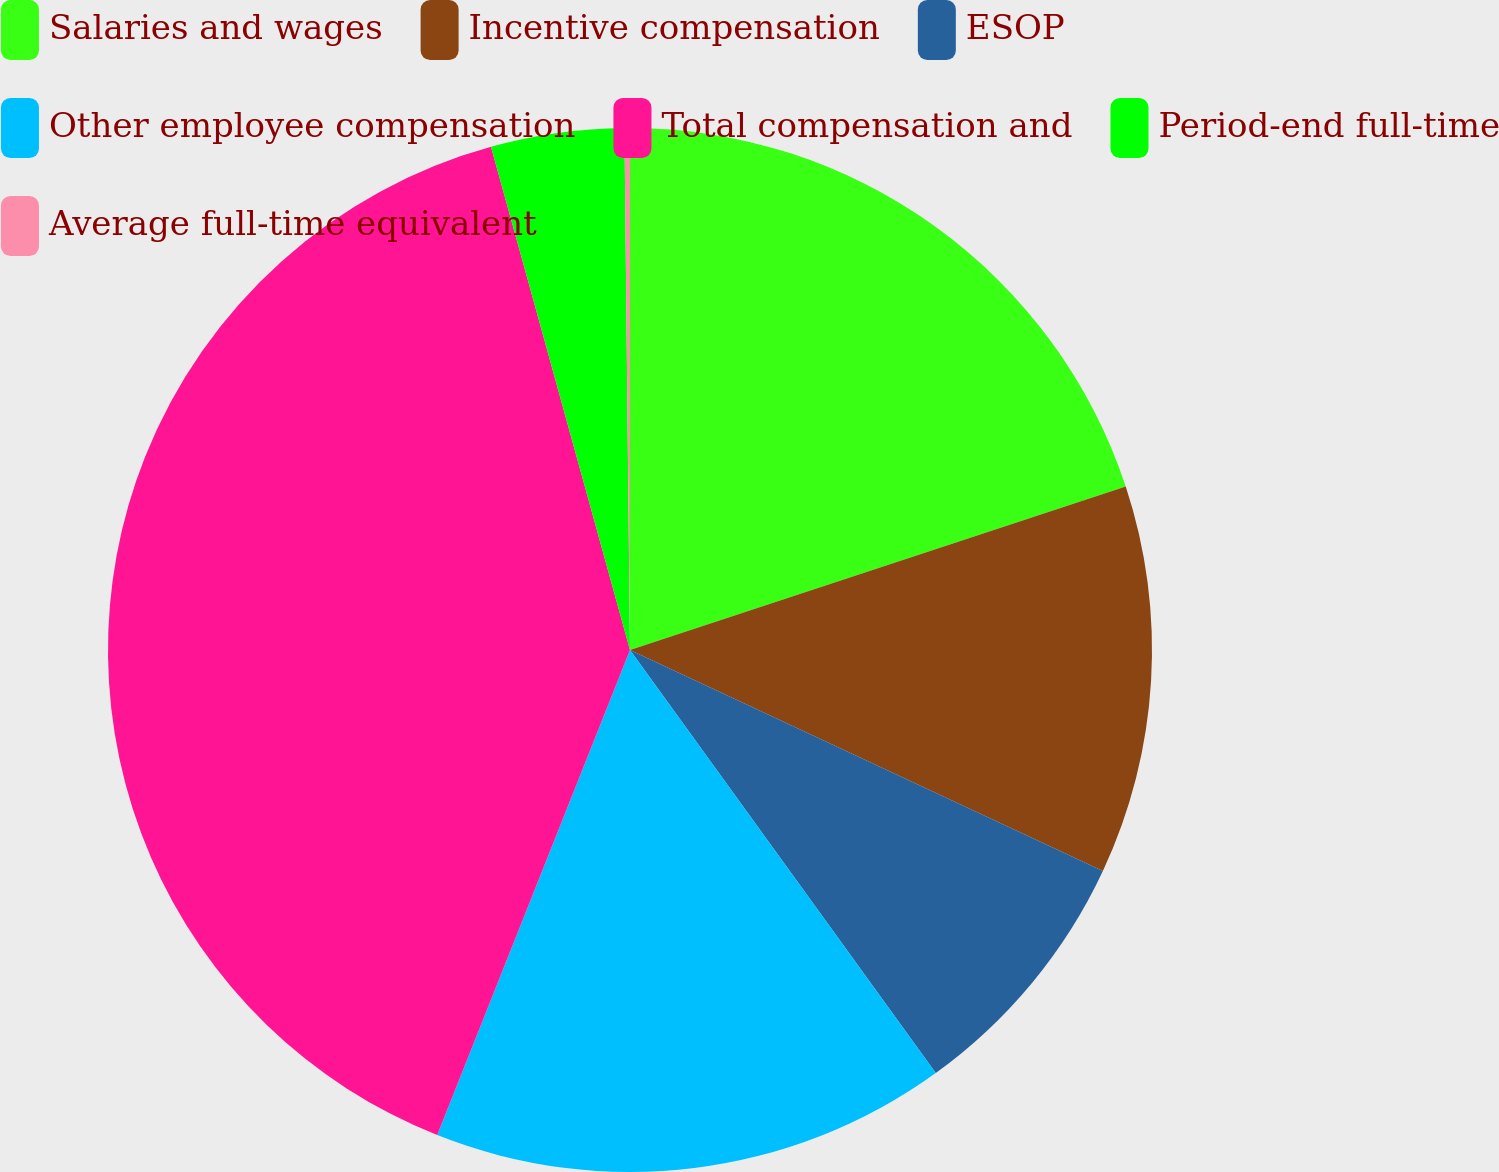Convert chart. <chart><loc_0><loc_0><loc_500><loc_500><pie_chart><fcel>Salaries and wages<fcel>Incentive compensation<fcel>ESOP<fcel>Other employee compensation<fcel>Total compensation and<fcel>Period-end full-time<fcel>Average full-time equivalent<nl><fcel>19.93%<fcel>12.03%<fcel>8.08%<fcel>15.98%<fcel>39.69%<fcel>4.12%<fcel>0.17%<nl></chart> 